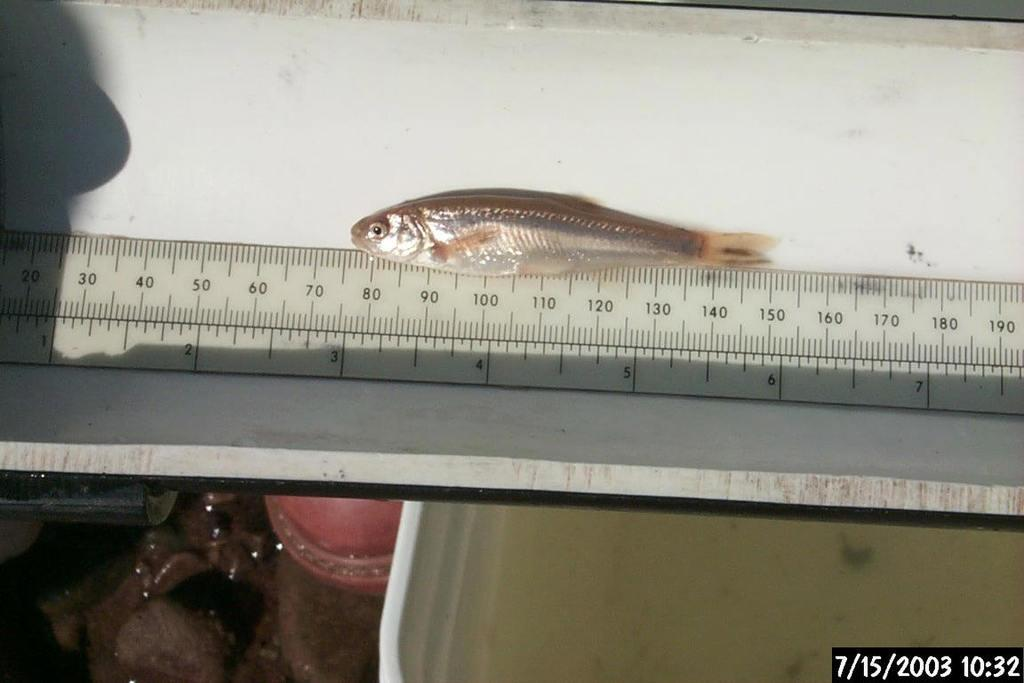What is the main object in the image? There is a scale in the image. What is placed on the scale? There is a fish on the scale. What surface is the scale placed on? The scale is placed on a table. Are there any other objects in the image besides the scale, fish, and table? Yes, there are other objects in the image. What additional information is provided in the image? The date and time are visible in the bottom right corner of the image. What type of curtain is hanging from the scale in the image? There is no curtain hanging from the scale in the image. 